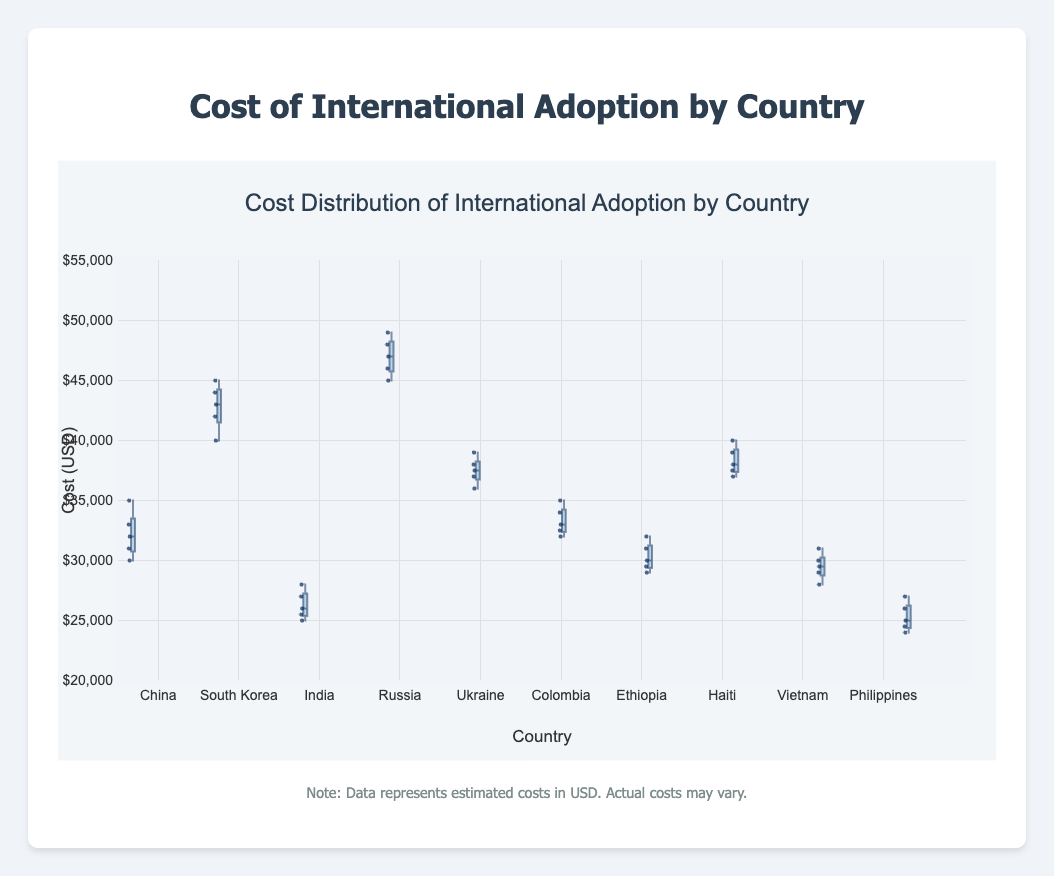What is the title of the box plot? The title of the box plot is clearly displayed at the top of the figure.
Answer: Cost Distribution of International Adoption by Country Which country shows the highest median cost for international adoption? Observe the middle line inside each box representing the median value. The country with the highest median line is Russia.
Answer: Russia What is the range of adoption costs for China? The range is determined by the minimum and maximum values, represented by the ends of the whiskers or outliers. For China, the costs range from $30,000 to $35,000.
Answer: $30,000 to $35,000 How does the median cost in South Korea compare to that in India? By examining the median lines in the box plots for South Korea and India, we see that South Korea has a higher median cost than India.
Answer: South Korea's median cost is higher Which country has the smallest interquartile range (IQR) for adoption costs? The interquartile range (IQR) is the distance between the first and third quartiles (~25% and ~75% of the data). By comparing the box lengths, we find that the Philippines have the smallest IQR.
Answer: Philippines What is the approximate difference between the highest costs in Haiti and Colombia? Identify the highest points (upper whiskers or outliers) for Haiti ($40,000) and Colombia ($35,000), and subtract the lower from the higher. The difference is $40,000 - $35,000.
Answer: $5,000 Is there any country that shows potential outliers in the data? Outliers are typically shown as individual points outside the whiskers. In this dataset, no country has visible points beyond whiskers, indicating no outliers.
Answer: No What is the average median cost for adoption from Vietnam and Ethiopia? Calculate the median cost for Vietnam and Ethiopia, add them, and divide by 2. Vietnam's median is $29,500, Ethiopia's is $30,000. So, ($29,500 + $30,000) / 2 = $29,750.
Answer: $29,750 On average, how do adoption costs in Ukraine compare to those in China? Compare the median lines of Ukraine ($37,500) and China ($32,000). Ukraine's median cost is higher than China's.
Answer: Ukraine's median cost is higher Which country has the most variability in adoption costs? Variability can be inferred from the length of the whiskers and the spread of the data points within the box. Russia shows the most variability with costs ranging from $45,000 to $49,000.
Answer: Russia 